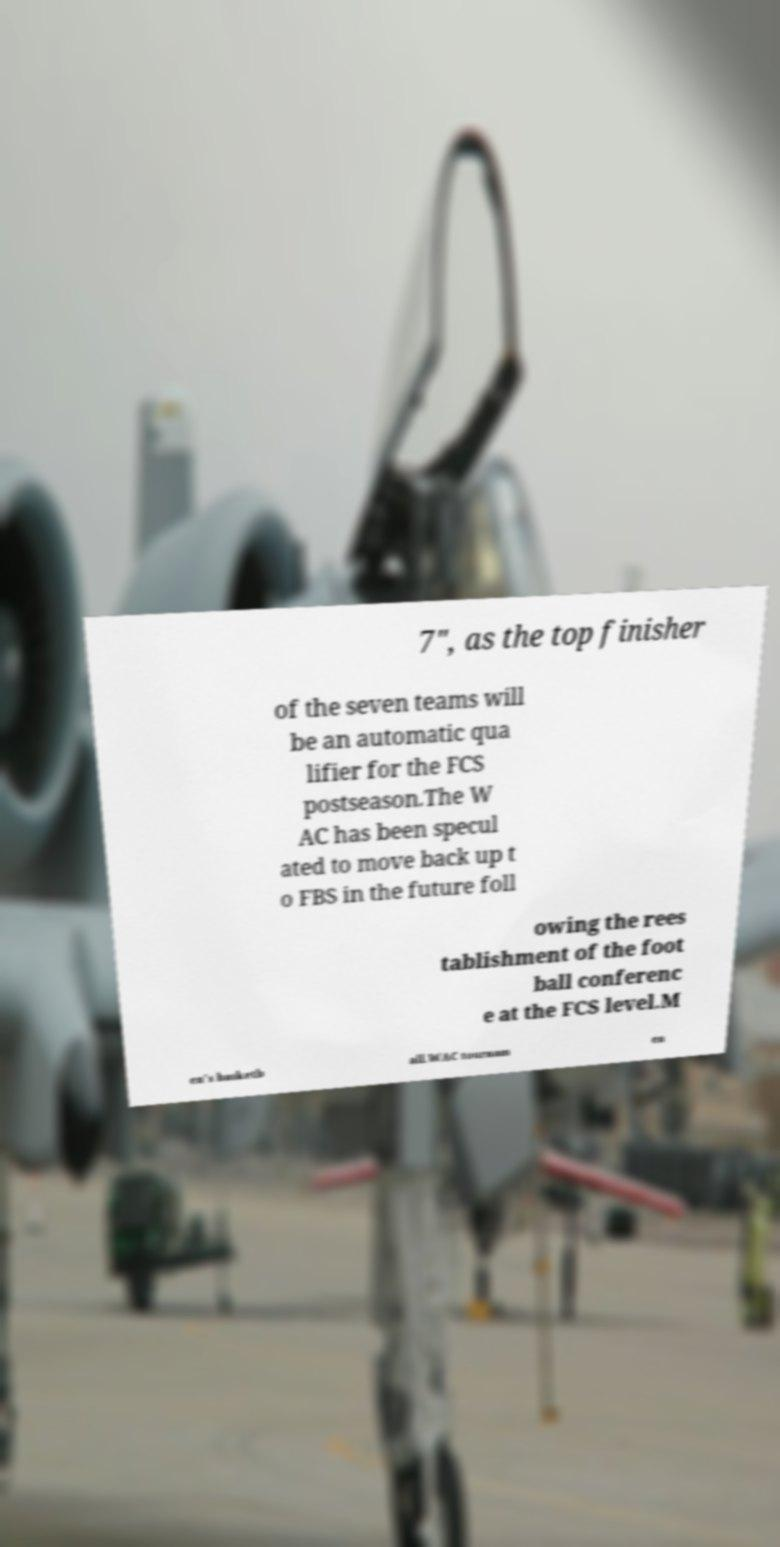For documentation purposes, I need the text within this image transcribed. Could you provide that? 7", as the top finisher of the seven teams will be an automatic qua lifier for the FCS postseason.The W AC has been specul ated to move back up t o FBS in the future foll owing the rees tablishment of the foot ball conferenc e at the FCS level.M en's basketb all.WAC tournam en 